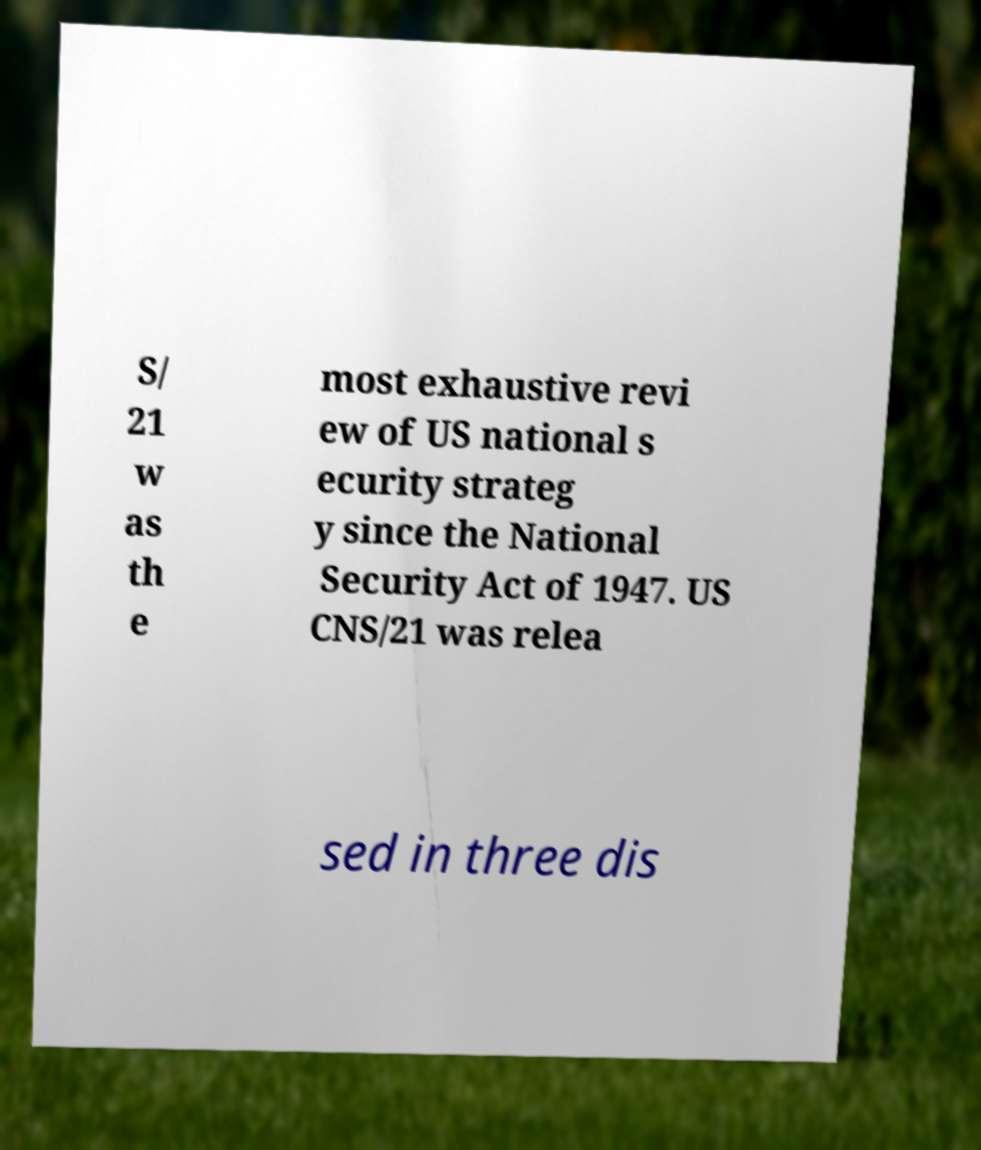Please read and relay the text visible in this image. What does it say? S/ 21 w as th e most exhaustive revi ew of US national s ecurity strateg y since the National Security Act of 1947. US CNS/21 was relea sed in three dis 